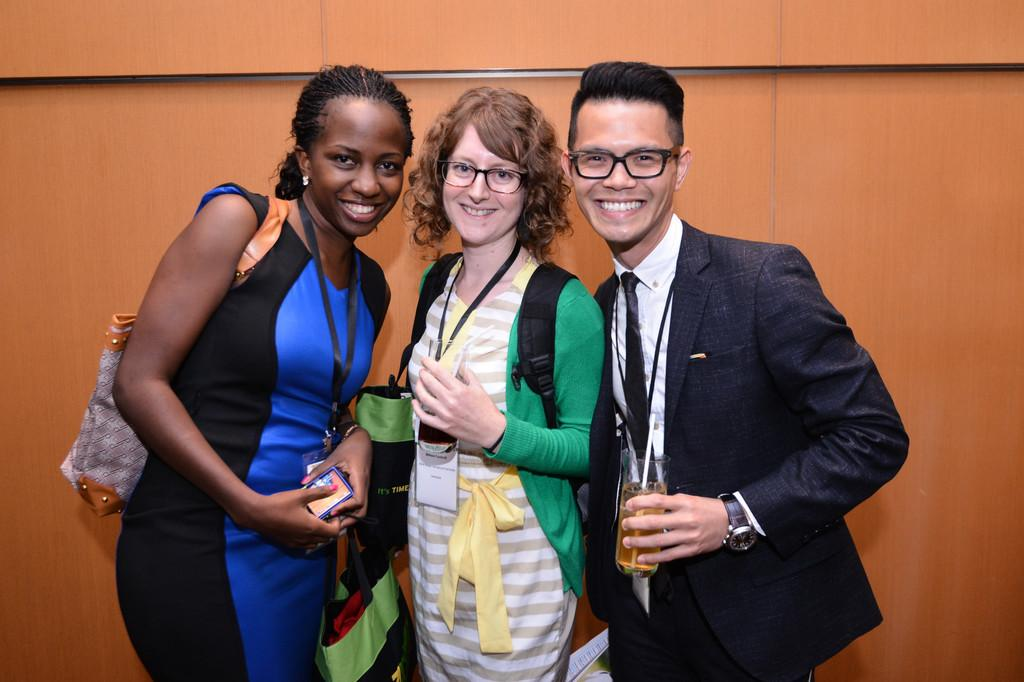How many people are in the image? There are three persons in the image. What is the facial expression of the people in the image? The persons are smiling. What can be seen in the background of the image? There is a wall in the background of the image. Are there any beggars visible in the image? There is no mention of a beggar in the image, so we cannot determine if one is present or not. What class are the persons in the image attending? The provided facts do not mention any class or educational setting, so we cannot determine the class they might be attending. 